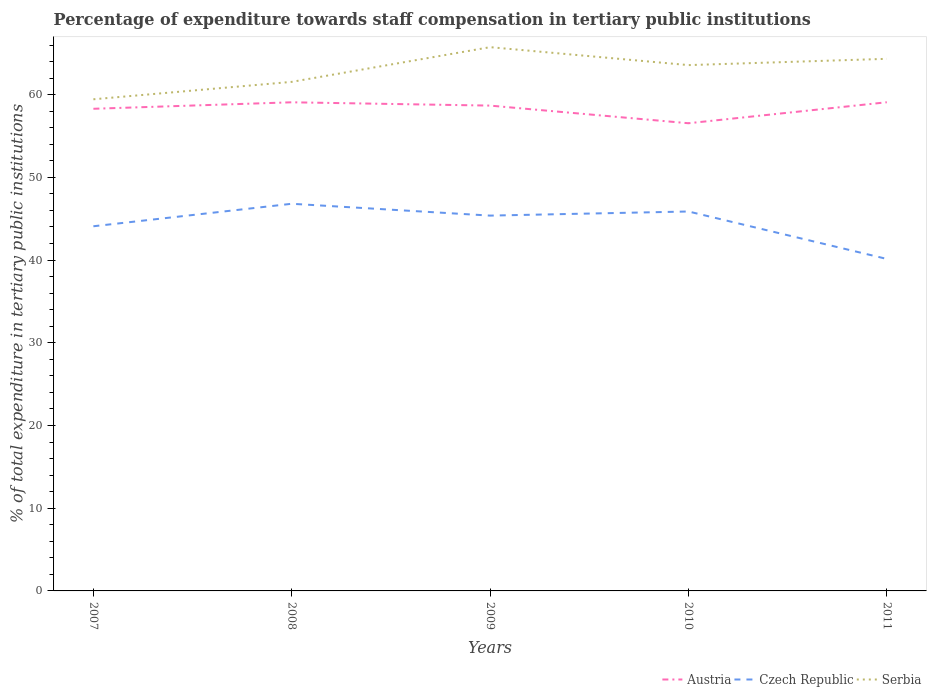Does the line corresponding to Serbia intersect with the line corresponding to Austria?
Give a very brief answer. No. Across all years, what is the maximum percentage of expenditure towards staff compensation in Czech Republic?
Give a very brief answer. 40.14. What is the total percentage of expenditure towards staff compensation in Austria in the graph?
Your response must be concise. 0.4. What is the difference between the highest and the second highest percentage of expenditure towards staff compensation in Czech Republic?
Give a very brief answer. 6.67. Is the percentage of expenditure towards staff compensation in Czech Republic strictly greater than the percentage of expenditure towards staff compensation in Serbia over the years?
Your answer should be very brief. Yes. How many years are there in the graph?
Ensure brevity in your answer.  5. What is the difference between two consecutive major ticks on the Y-axis?
Offer a very short reply. 10. Are the values on the major ticks of Y-axis written in scientific E-notation?
Give a very brief answer. No. Does the graph contain any zero values?
Make the answer very short. No. What is the title of the graph?
Your answer should be very brief. Percentage of expenditure towards staff compensation in tertiary public institutions. Does "China" appear as one of the legend labels in the graph?
Your answer should be compact. No. What is the label or title of the X-axis?
Give a very brief answer. Years. What is the label or title of the Y-axis?
Provide a short and direct response. % of total expenditure in tertiary public institutions. What is the % of total expenditure in tertiary public institutions of Austria in 2007?
Offer a terse response. 58.29. What is the % of total expenditure in tertiary public institutions of Czech Republic in 2007?
Ensure brevity in your answer.  44.09. What is the % of total expenditure in tertiary public institutions in Serbia in 2007?
Your answer should be compact. 59.44. What is the % of total expenditure in tertiary public institutions in Austria in 2008?
Provide a succinct answer. 59.08. What is the % of total expenditure in tertiary public institutions of Czech Republic in 2008?
Provide a short and direct response. 46.81. What is the % of total expenditure in tertiary public institutions in Serbia in 2008?
Your answer should be compact. 61.55. What is the % of total expenditure in tertiary public institutions of Austria in 2009?
Your answer should be very brief. 58.68. What is the % of total expenditure in tertiary public institutions of Czech Republic in 2009?
Make the answer very short. 45.38. What is the % of total expenditure in tertiary public institutions of Serbia in 2009?
Your answer should be compact. 65.74. What is the % of total expenditure in tertiary public institutions in Austria in 2010?
Provide a succinct answer. 56.54. What is the % of total expenditure in tertiary public institutions of Czech Republic in 2010?
Offer a terse response. 45.87. What is the % of total expenditure in tertiary public institutions of Serbia in 2010?
Your answer should be very brief. 63.57. What is the % of total expenditure in tertiary public institutions in Austria in 2011?
Your answer should be very brief. 59.08. What is the % of total expenditure in tertiary public institutions of Czech Republic in 2011?
Offer a very short reply. 40.14. What is the % of total expenditure in tertiary public institutions in Serbia in 2011?
Your response must be concise. 64.33. Across all years, what is the maximum % of total expenditure in tertiary public institutions of Austria?
Your response must be concise. 59.08. Across all years, what is the maximum % of total expenditure in tertiary public institutions in Czech Republic?
Provide a succinct answer. 46.81. Across all years, what is the maximum % of total expenditure in tertiary public institutions in Serbia?
Ensure brevity in your answer.  65.74. Across all years, what is the minimum % of total expenditure in tertiary public institutions of Austria?
Provide a short and direct response. 56.54. Across all years, what is the minimum % of total expenditure in tertiary public institutions in Czech Republic?
Give a very brief answer. 40.14. Across all years, what is the minimum % of total expenditure in tertiary public institutions in Serbia?
Provide a succinct answer. 59.44. What is the total % of total expenditure in tertiary public institutions in Austria in the graph?
Keep it short and to the point. 291.67. What is the total % of total expenditure in tertiary public institutions in Czech Republic in the graph?
Give a very brief answer. 222.29. What is the total % of total expenditure in tertiary public institutions of Serbia in the graph?
Provide a succinct answer. 314.64. What is the difference between the % of total expenditure in tertiary public institutions of Austria in 2007 and that in 2008?
Keep it short and to the point. -0.78. What is the difference between the % of total expenditure in tertiary public institutions of Czech Republic in 2007 and that in 2008?
Your response must be concise. -2.72. What is the difference between the % of total expenditure in tertiary public institutions of Serbia in 2007 and that in 2008?
Make the answer very short. -2.11. What is the difference between the % of total expenditure in tertiary public institutions in Austria in 2007 and that in 2009?
Give a very brief answer. -0.38. What is the difference between the % of total expenditure in tertiary public institutions of Czech Republic in 2007 and that in 2009?
Make the answer very short. -1.29. What is the difference between the % of total expenditure in tertiary public institutions of Serbia in 2007 and that in 2009?
Provide a succinct answer. -6.3. What is the difference between the % of total expenditure in tertiary public institutions in Austria in 2007 and that in 2010?
Keep it short and to the point. 1.75. What is the difference between the % of total expenditure in tertiary public institutions of Czech Republic in 2007 and that in 2010?
Your response must be concise. -1.79. What is the difference between the % of total expenditure in tertiary public institutions in Serbia in 2007 and that in 2010?
Make the answer very short. -4.13. What is the difference between the % of total expenditure in tertiary public institutions in Austria in 2007 and that in 2011?
Keep it short and to the point. -0.79. What is the difference between the % of total expenditure in tertiary public institutions in Czech Republic in 2007 and that in 2011?
Give a very brief answer. 3.95. What is the difference between the % of total expenditure in tertiary public institutions in Serbia in 2007 and that in 2011?
Provide a succinct answer. -4.89. What is the difference between the % of total expenditure in tertiary public institutions in Austria in 2008 and that in 2009?
Your response must be concise. 0.4. What is the difference between the % of total expenditure in tertiary public institutions in Czech Republic in 2008 and that in 2009?
Ensure brevity in your answer.  1.43. What is the difference between the % of total expenditure in tertiary public institutions in Serbia in 2008 and that in 2009?
Your answer should be very brief. -4.19. What is the difference between the % of total expenditure in tertiary public institutions in Austria in 2008 and that in 2010?
Offer a terse response. 2.53. What is the difference between the % of total expenditure in tertiary public institutions in Czech Republic in 2008 and that in 2010?
Your answer should be very brief. 0.93. What is the difference between the % of total expenditure in tertiary public institutions in Serbia in 2008 and that in 2010?
Your answer should be very brief. -2.03. What is the difference between the % of total expenditure in tertiary public institutions of Austria in 2008 and that in 2011?
Offer a very short reply. -0. What is the difference between the % of total expenditure in tertiary public institutions in Czech Republic in 2008 and that in 2011?
Ensure brevity in your answer.  6.67. What is the difference between the % of total expenditure in tertiary public institutions of Serbia in 2008 and that in 2011?
Your response must be concise. -2.79. What is the difference between the % of total expenditure in tertiary public institutions in Austria in 2009 and that in 2010?
Your answer should be very brief. 2.13. What is the difference between the % of total expenditure in tertiary public institutions in Czech Republic in 2009 and that in 2010?
Keep it short and to the point. -0.5. What is the difference between the % of total expenditure in tertiary public institutions in Serbia in 2009 and that in 2010?
Make the answer very short. 2.17. What is the difference between the % of total expenditure in tertiary public institutions in Austria in 2009 and that in 2011?
Make the answer very short. -0.4. What is the difference between the % of total expenditure in tertiary public institutions in Czech Republic in 2009 and that in 2011?
Your answer should be very brief. 5.24. What is the difference between the % of total expenditure in tertiary public institutions of Serbia in 2009 and that in 2011?
Offer a very short reply. 1.41. What is the difference between the % of total expenditure in tertiary public institutions of Austria in 2010 and that in 2011?
Offer a very short reply. -2.54. What is the difference between the % of total expenditure in tertiary public institutions in Czech Republic in 2010 and that in 2011?
Provide a succinct answer. 5.74. What is the difference between the % of total expenditure in tertiary public institutions in Serbia in 2010 and that in 2011?
Give a very brief answer. -0.76. What is the difference between the % of total expenditure in tertiary public institutions of Austria in 2007 and the % of total expenditure in tertiary public institutions of Czech Republic in 2008?
Keep it short and to the point. 11.48. What is the difference between the % of total expenditure in tertiary public institutions of Austria in 2007 and the % of total expenditure in tertiary public institutions of Serbia in 2008?
Your response must be concise. -3.25. What is the difference between the % of total expenditure in tertiary public institutions in Czech Republic in 2007 and the % of total expenditure in tertiary public institutions in Serbia in 2008?
Give a very brief answer. -17.46. What is the difference between the % of total expenditure in tertiary public institutions of Austria in 2007 and the % of total expenditure in tertiary public institutions of Czech Republic in 2009?
Your answer should be very brief. 12.92. What is the difference between the % of total expenditure in tertiary public institutions of Austria in 2007 and the % of total expenditure in tertiary public institutions of Serbia in 2009?
Ensure brevity in your answer.  -7.45. What is the difference between the % of total expenditure in tertiary public institutions in Czech Republic in 2007 and the % of total expenditure in tertiary public institutions in Serbia in 2009?
Offer a very short reply. -21.65. What is the difference between the % of total expenditure in tertiary public institutions in Austria in 2007 and the % of total expenditure in tertiary public institutions in Czech Republic in 2010?
Offer a very short reply. 12.42. What is the difference between the % of total expenditure in tertiary public institutions in Austria in 2007 and the % of total expenditure in tertiary public institutions in Serbia in 2010?
Give a very brief answer. -5.28. What is the difference between the % of total expenditure in tertiary public institutions in Czech Republic in 2007 and the % of total expenditure in tertiary public institutions in Serbia in 2010?
Ensure brevity in your answer.  -19.48. What is the difference between the % of total expenditure in tertiary public institutions of Austria in 2007 and the % of total expenditure in tertiary public institutions of Czech Republic in 2011?
Ensure brevity in your answer.  18.15. What is the difference between the % of total expenditure in tertiary public institutions of Austria in 2007 and the % of total expenditure in tertiary public institutions of Serbia in 2011?
Keep it short and to the point. -6.04. What is the difference between the % of total expenditure in tertiary public institutions of Czech Republic in 2007 and the % of total expenditure in tertiary public institutions of Serbia in 2011?
Ensure brevity in your answer.  -20.24. What is the difference between the % of total expenditure in tertiary public institutions in Austria in 2008 and the % of total expenditure in tertiary public institutions in Czech Republic in 2009?
Ensure brevity in your answer.  13.7. What is the difference between the % of total expenditure in tertiary public institutions of Austria in 2008 and the % of total expenditure in tertiary public institutions of Serbia in 2009?
Your response must be concise. -6.67. What is the difference between the % of total expenditure in tertiary public institutions of Czech Republic in 2008 and the % of total expenditure in tertiary public institutions of Serbia in 2009?
Your answer should be very brief. -18.93. What is the difference between the % of total expenditure in tertiary public institutions in Austria in 2008 and the % of total expenditure in tertiary public institutions in Czech Republic in 2010?
Offer a very short reply. 13.2. What is the difference between the % of total expenditure in tertiary public institutions of Austria in 2008 and the % of total expenditure in tertiary public institutions of Serbia in 2010?
Make the answer very short. -4.5. What is the difference between the % of total expenditure in tertiary public institutions of Czech Republic in 2008 and the % of total expenditure in tertiary public institutions of Serbia in 2010?
Your answer should be compact. -16.76. What is the difference between the % of total expenditure in tertiary public institutions of Austria in 2008 and the % of total expenditure in tertiary public institutions of Czech Republic in 2011?
Provide a succinct answer. 18.94. What is the difference between the % of total expenditure in tertiary public institutions of Austria in 2008 and the % of total expenditure in tertiary public institutions of Serbia in 2011?
Make the answer very short. -5.26. What is the difference between the % of total expenditure in tertiary public institutions of Czech Republic in 2008 and the % of total expenditure in tertiary public institutions of Serbia in 2011?
Your response must be concise. -17.52. What is the difference between the % of total expenditure in tertiary public institutions of Austria in 2009 and the % of total expenditure in tertiary public institutions of Czech Republic in 2010?
Offer a terse response. 12.8. What is the difference between the % of total expenditure in tertiary public institutions in Austria in 2009 and the % of total expenditure in tertiary public institutions in Serbia in 2010?
Make the answer very short. -4.9. What is the difference between the % of total expenditure in tertiary public institutions in Czech Republic in 2009 and the % of total expenditure in tertiary public institutions in Serbia in 2010?
Keep it short and to the point. -18.2. What is the difference between the % of total expenditure in tertiary public institutions in Austria in 2009 and the % of total expenditure in tertiary public institutions in Czech Republic in 2011?
Keep it short and to the point. 18.54. What is the difference between the % of total expenditure in tertiary public institutions of Austria in 2009 and the % of total expenditure in tertiary public institutions of Serbia in 2011?
Your response must be concise. -5.66. What is the difference between the % of total expenditure in tertiary public institutions of Czech Republic in 2009 and the % of total expenditure in tertiary public institutions of Serbia in 2011?
Your answer should be very brief. -18.96. What is the difference between the % of total expenditure in tertiary public institutions in Austria in 2010 and the % of total expenditure in tertiary public institutions in Czech Republic in 2011?
Your response must be concise. 16.41. What is the difference between the % of total expenditure in tertiary public institutions in Austria in 2010 and the % of total expenditure in tertiary public institutions in Serbia in 2011?
Ensure brevity in your answer.  -7.79. What is the difference between the % of total expenditure in tertiary public institutions of Czech Republic in 2010 and the % of total expenditure in tertiary public institutions of Serbia in 2011?
Make the answer very short. -18.46. What is the average % of total expenditure in tertiary public institutions of Austria per year?
Offer a very short reply. 58.33. What is the average % of total expenditure in tertiary public institutions in Czech Republic per year?
Provide a short and direct response. 44.46. What is the average % of total expenditure in tertiary public institutions in Serbia per year?
Provide a succinct answer. 62.93. In the year 2007, what is the difference between the % of total expenditure in tertiary public institutions of Austria and % of total expenditure in tertiary public institutions of Czech Republic?
Ensure brevity in your answer.  14.21. In the year 2007, what is the difference between the % of total expenditure in tertiary public institutions in Austria and % of total expenditure in tertiary public institutions in Serbia?
Provide a succinct answer. -1.15. In the year 2007, what is the difference between the % of total expenditure in tertiary public institutions in Czech Republic and % of total expenditure in tertiary public institutions in Serbia?
Keep it short and to the point. -15.35. In the year 2008, what is the difference between the % of total expenditure in tertiary public institutions in Austria and % of total expenditure in tertiary public institutions in Czech Republic?
Make the answer very short. 12.27. In the year 2008, what is the difference between the % of total expenditure in tertiary public institutions in Austria and % of total expenditure in tertiary public institutions in Serbia?
Offer a very short reply. -2.47. In the year 2008, what is the difference between the % of total expenditure in tertiary public institutions in Czech Republic and % of total expenditure in tertiary public institutions in Serbia?
Your answer should be compact. -14.74. In the year 2009, what is the difference between the % of total expenditure in tertiary public institutions of Austria and % of total expenditure in tertiary public institutions of Czech Republic?
Your response must be concise. 13.3. In the year 2009, what is the difference between the % of total expenditure in tertiary public institutions of Austria and % of total expenditure in tertiary public institutions of Serbia?
Your response must be concise. -7.07. In the year 2009, what is the difference between the % of total expenditure in tertiary public institutions of Czech Republic and % of total expenditure in tertiary public institutions of Serbia?
Keep it short and to the point. -20.37. In the year 2010, what is the difference between the % of total expenditure in tertiary public institutions in Austria and % of total expenditure in tertiary public institutions in Czech Republic?
Your response must be concise. 10.67. In the year 2010, what is the difference between the % of total expenditure in tertiary public institutions in Austria and % of total expenditure in tertiary public institutions in Serbia?
Offer a very short reply. -7.03. In the year 2010, what is the difference between the % of total expenditure in tertiary public institutions of Czech Republic and % of total expenditure in tertiary public institutions of Serbia?
Give a very brief answer. -17.7. In the year 2011, what is the difference between the % of total expenditure in tertiary public institutions in Austria and % of total expenditure in tertiary public institutions in Czech Republic?
Make the answer very short. 18.94. In the year 2011, what is the difference between the % of total expenditure in tertiary public institutions in Austria and % of total expenditure in tertiary public institutions in Serbia?
Keep it short and to the point. -5.25. In the year 2011, what is the difference between the % of total expenditure in tertiary public institutions in Czech Republic and % of total expenditure in tertiary public institutions in Serbia?
Your response must be concise. -24.19. What is the ratio of the % of total expenditure in tertiary public institutions in Austria in 2007 to that in 2008?
Make the answer very short. 0.99. What is the ratio of the % of total expenditure in tertiary public institutions of Czech Republic in 2007 to that in 2008?
Your response must be concise. 0.94. What is the ratio of the % of total expenditure in tertiary public institutions in Serbia in 2007 to that in 2008?
Ensure brevity in your answer.  0.97. What is the ratio of the % of total expenditure in tertiary public institutions in Austria in 2007 to that in 2009?
Your response must be concise. 0.99. What is the ratio of the % of total expenditure in tertiary public institutions in Czech Republic in 2007 to that in 2009?
Offer a very short reply. 0.97. What is the ratio of the % of total expenditure in tertiary public institutions of Serbia in 2007 to that in 2009?
Make the answer very short. 0.9. What is the ratio of the % of total expenditure in tertiary public institutions in Austria in 2007 to that in 2010?
Make the answer very short. 1.03. What is the ratio of the % of total expenditure in tertiary public institutions in Czech Republic in 2007 to that in 2010?
Keep it short and to the point. 0.96. What is the ratio of the % of total expenditure in tertiary public institutions in Serbia in 2007 to that in 2010?
Your answer should be very brief. 0.94. What is the ratio of the % of total expenditure in tertiary public institutions in Austria in 2007 to that in 2011?
Offer a terse response. 0.99. What is the ratio of the % of total expenditure in tertiary public institutions in Czech Republic in 2007 to that in 2011?
Provide a succinct answer. 1.1. What is the ratio of the % of total expenditure in tertiary public institutions of Serbia in 2007 to that in 2011?
Your answer should be very brief. 0.92. What is the ratio of the % of total expenditure in tertiary public institutions of Austria in 2008 to that in 2009?
Your answer should be very brief. 1.01. What is the ratio of the % of total expenditure in tertiary public institutions of Czech Republic in 2008 to that in 2009?
Make the answer very short. 1.03. What is the ratio of the % of total expenditure in tertiary public institutions of Serbia in 2008 to that in 2009?
Offer a very short reply. 0.94. What is the ratio of the % of total expenditure in tertiary public institutions in Austria in 2008 to that in 2010?
Provide a short and direct response. 1.04. What is the ratio of the % of total expenditure in tertiary public institutions of Czech Republic in 2008 to that in 2010?
Your response must be concise. 1.02. What is the ratio of the % of total expenditure in tertiary public institutions in Serbia in 2008 to that in 2010?
Provide a short and direct response. 0.97. What is the ratio of the % of total expenditure in tertiary public institutions in Czech Republic in 2008 to that in 2011?
Your answer should be compact. 1.17. What is the ratio of the % of total expenditure in tertiary public institutions of Serbia in 2008 to that in 2011?
Offer a very short reply. 0.96. What is the ratio of the % of total expenditure in tertiary public institutions of Austria in 2009 to that in 2010?
Offer a very short reply. 1.04. What is the ratio of the % of total expenditure in tertiary public institutions of Czech Republic in 2009 to that in 2010?
Offer a very short reply. 0.99. What is the ratio of the % of total expenditure in tertiary public institutions of Serbia in 2009 to that in 2010?
Make the answer very short. 1.03. What is the ratio of the % of total expenditure in tertiary public institutions in Austria in 2009 to that in 2011?
Provide a succinct answer. 0.99. What is the ratio of the % of total expenditure in tertiary public institutions in Czech Republic in 2009 to that in 2011?
Your response must be concise. 1.13. What is the ratio of the % of total expenditure in tertiary public institutions in Serbia in 2009 to that in 2011?
Offer a very short reply. 1.02. What is the ratio of the % of total expenditure in tertiary public institutions in Austria in 2010 to that in 2011?
Keep it short and to the point. 0.96. What is the ratio of the % of total expenditure in tertiary public institutions of Serbia in 2010 to that in 2011?
Your answer should be compact. 0.99. What is the difference between the highest and the second highest % of total expenditure in tertiary public institutions of Austria?
Offer a terse response. 0. What is the difference between the highest and the second highest % of total expenditure in tertiary public institutions in Czech Republic?
Keep it short and to the point. 0.93. What is the difference between the highest and the second highest % of total expenditure in tertiary public institutions in Serbia?
Keep it short and to the point. 1.41. What is the difference between the highest and the lowest % of total expenditure in tertiary public institutions of Austria?
Provide a short and direct response. 2.54. What is the difference between the highest and the lowest % of total expenditure in tertiary public institutions of Czech Republic?
Provide a short and direct response. 6.67. What is the difference between the highest and the lowest % of total expenditure in tertiary public institutions of Serbia?
Provide a short and direct response. 6.3. 